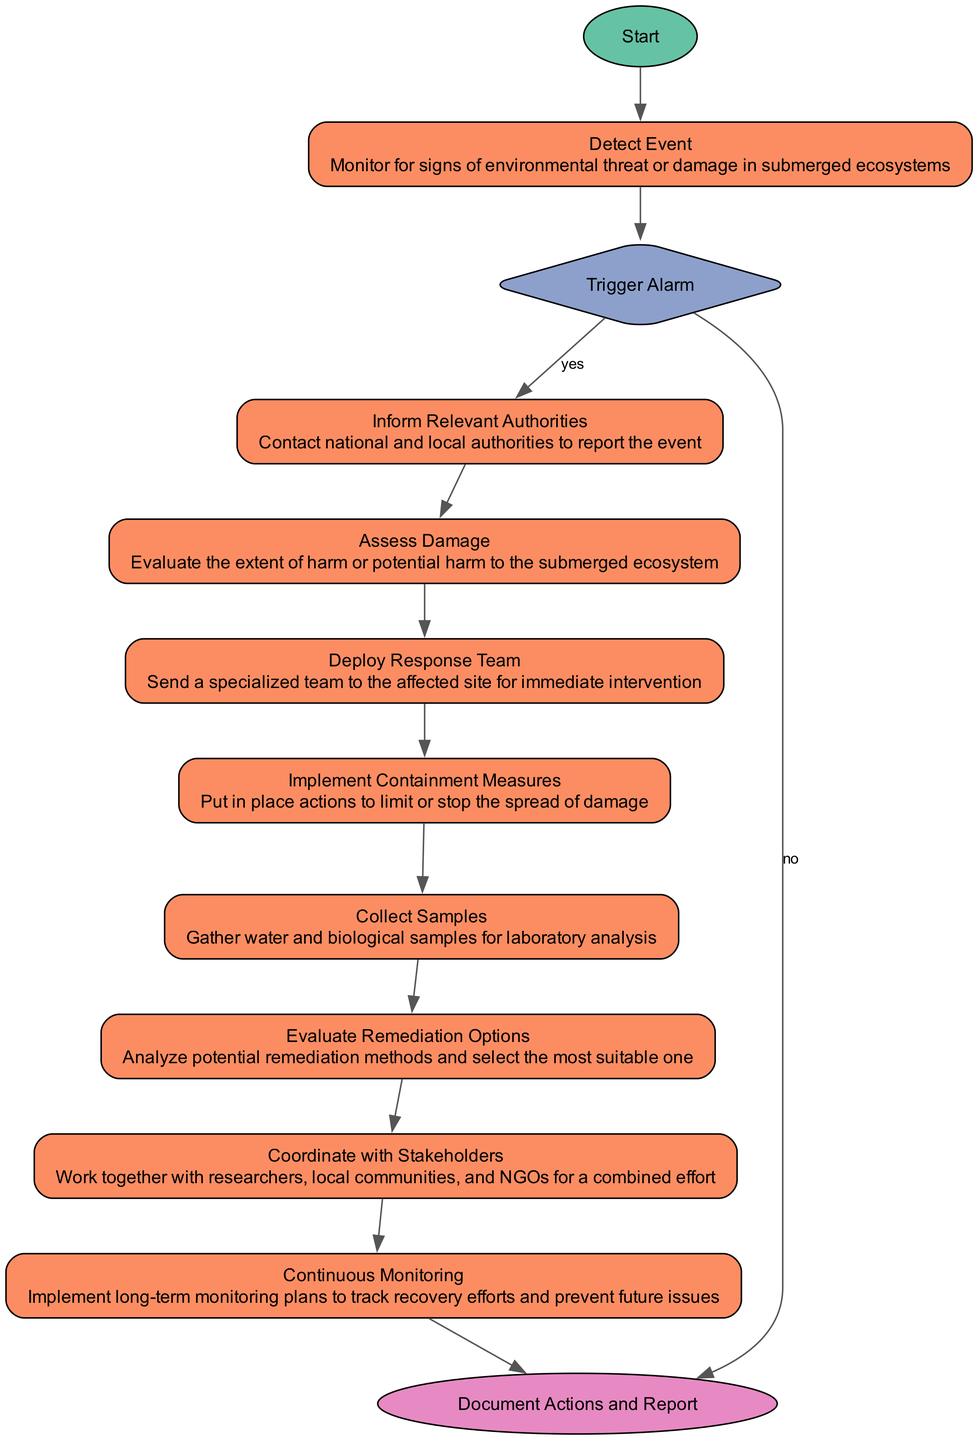What is the first action in the diagram? The first action in the diagram is "Detect Event," represented by the node following the "Start" node.
Answer: Detect Event How many actions are there in total? By counting the nodes classified as actions, there are six actions: "Inform Relevant Authorities," "Assess Damage," "Deploy Response Team," "Implement Containment Measures," "Collect Samples," "Evaluate Remediation," and "Coordinate with Stakeholders."
Answer: 6 What happens after "Assess Damage"? After "Assess Damage," the next action is "Deploy Response Team," which means that this node follows immediately in the flow of the diagram.
Answer: Deploy Response Team What is the decision node in the diagram called? The decision node is labeled "Trigger Alarm," and it determines whether the incident requires further intervention.
Answer: Trigger Alarm Which action follows the "Collect Samples" node? The action that follows "Collect Samples" is "Evaluate Remediation Options," indicating that after samples are collected, evaluating remediation methods is the next step.
Answer: Evaluate Remediation Options What is the last action documented in the flow? The last action in the flow is "Document Actions and Report," which is a finish node that signifies the completion of the emergency response process.
Answer: Document Actions and Report What condition leads to "Document Actions and Report" from "Trigger Alarm"? If the condition is "no," it indicates that no emergency response is required, leading directly to "Document Actions and Report."
Answer: no How many transitions are there in the diagram? The transitions represent the connections between nodes, and counting these reveals there are twelve transitions in the diagram.
Answer: 12 What role does the "Coordinate with Stakeholders" action play in the diagram? This action indicates collaboration with various entities to enhance the response efforts and support ecosystem protection, positioned as a step before ongoing monitoring.
Answer: Collaboration 